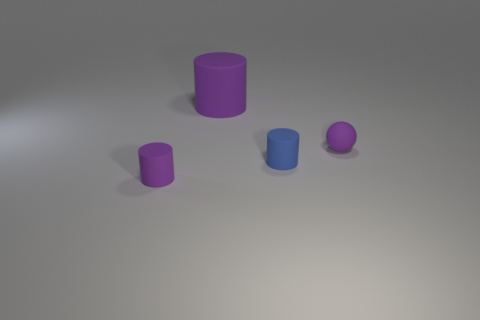The small object that is on the right side of the tiny purple matte cylinder and to the left of the purple matte ball is made of what material?
Your answer should be very brief. Rubber. Are there an equal number of cylinders that are in front of the tiny purple matte cylinder and small objects?
Offer a terse response. No. How many large gray matte objects have the same shape as the big purple thing?
Make the answer very short. 0. There is a purple rubber cylinder on the left side of the purple rubber cylinder right of the purple matte object left of the big matte object; how big is it?
Offer a terse response. Small. Is the purple object that is behind the rubber sphere made of the same material as the small purple cylinder?
Provide a succinct answer. Yes. Are there the same number of large purple objects left of the big rubber cylinder and small purple rubber objects that are behind the tiny blue matte cylinder?
Give a very brief answer. No. Is there any other thing that is the same size as the blue rubber cylinder?
Your answer should be compact. Yes. What is the material of the big purple thing that is the same shape as the blue rubber object?
Provide a short and direct response. Rubber. There is a purple thing in front of the tiny purple object that is to the right of the small purple cylinder; is there a small thing that is on the right side of it?
Make the answer very short. Yes. Is the shape of the purple rubber object that is on the right side of the big rubber cylinder the same as the object in front of the blue thing?
Make the answer very short. No. 